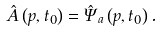Convert formula to latex. <formula><loc_0><loc_0><loc_500><loc_500>\hat { A } \left ( { p } , t _ { 0 } \right ) = \hat { \Psi } _ { a } \left ( { p } , t _ { 0 } \right ) .</formula> 